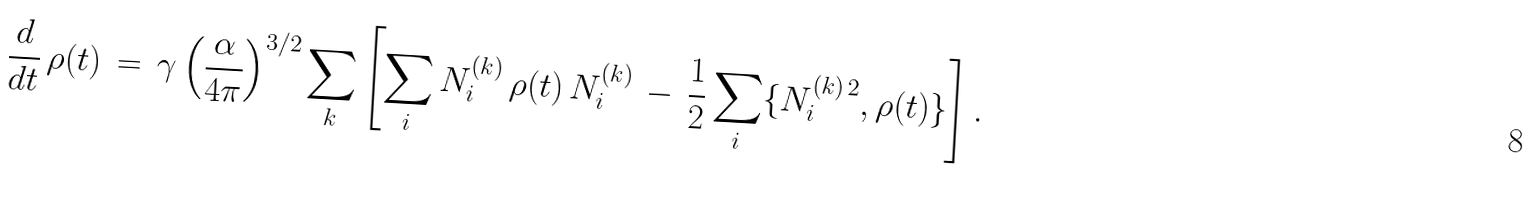Convert formula to latex. <formula><loc_0><loc_0><loc_500><loc_500>\frac { d } { d t } \, \rho ( t ) \, = \, \gamma \left ( \frac { \alpha } { 4 \pi } \right ) ^ { 3 / 2 } \sum _ { k } \left [ \sum _ { i } N _ { i } ^ { ( k ) } \, \rho ( t ) \, N _ { i } ^ { ( k ) } \, - \, \frac { 1 } { 2 } \sum _ { i } \{ N _ { i } ^ { ( k ) \, 2 } , \rho ( t ) \} \right ] .</formula> 